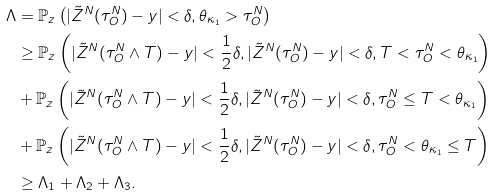<formula> <loc_0><loc_0><loc_500><loc_500>\Lambda & = \mathbb { P } _ { z } \left ( | \tilde { Z } ^ { N } ( \tau ^ { N } _ { O } ) - y | < \delta , \theta _ { \kappa _ { 1 } } > \tau _ { O } ^ { N } \right ) \\ & \geq \mathbb { P } _ { z } \left ( | \tilde { Z } ^ { N } ( \tau ^ { N } _ { O } \wedge T ) - y | < \frac { 1 } { 2 } \delta , | \tilde { Z } ^ { N } ( \tau ^ { N } _ { O } ) - y | < \delta , T < \tau ^ { N } _ { O } < \theta _ { \kappa _ { 1 } } \right ) \\ & + \mathbb { P } _ { z } \left ( | \tilde { Z } ^ { N } ( \tau ^ { N } _ { O } \wedge T ) - y | < \frac { 1 } { 2 } \delta , | \tilde { Z } ^ { N } ( \tau ^ { N } _ { O } ) - y | < \delta , \tau ^ { N } _ { O } \leq T < \theta _ { \kappa _ { 1 } } \right ) \\ & + \mathbb { P } _ { z } \left ( | \tilde { Z } ^ { N } ( \tau ^ { N } _ { O } \wedge T ) - y | < \frac { 1 } { 2 } \delta , | \tilde { Z } ^ { N } ( \tau ^ { N } _ { O } ) - y | < \delta , \tau ^ { N } _ { O } < \theta _ { \kappa _ { 1 } } \leq T \right ) \\ & \geq \Lambda _ { 1 } + \Lambda _ { 2 } + \Lambda _ { 3 } .</formula> 